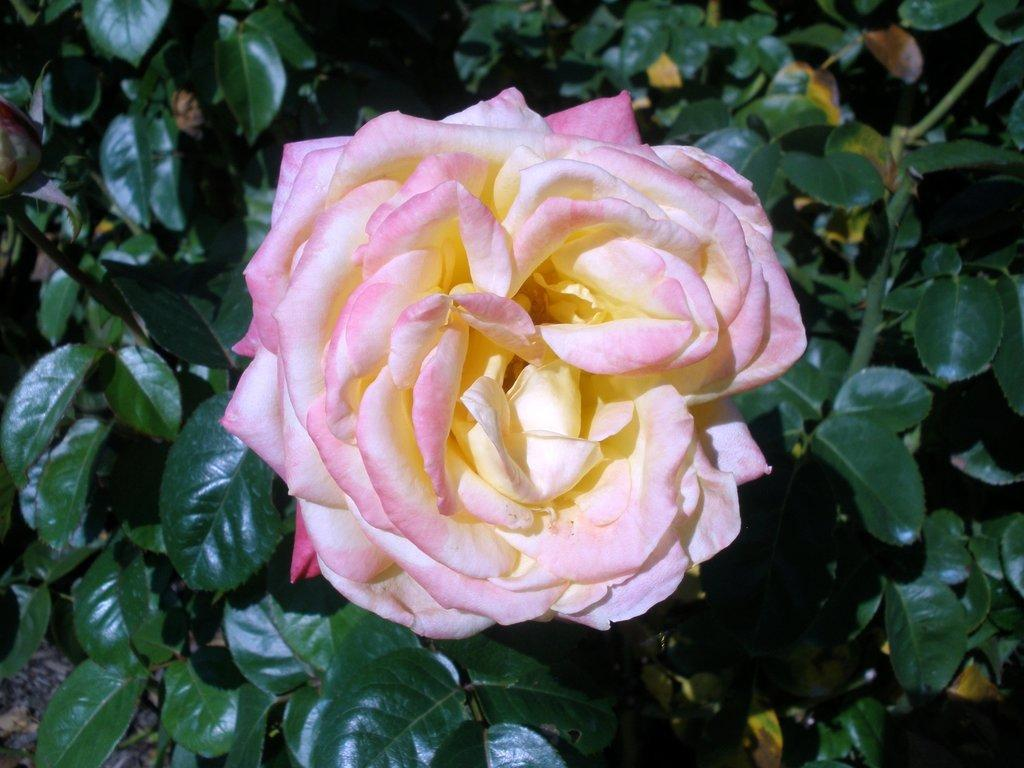What is the main subject of the image? There is a flower in the image. Can you describe the colors of the flower? The flower has white and pink colors. What can be seen in the background of the image? There are plants and green leaves in the background of the image. What type of instrument can be seen in the image? There is no instrument present in the image; it features a flower with white and pink colors, surrounded by plants and green leaves in the background. 